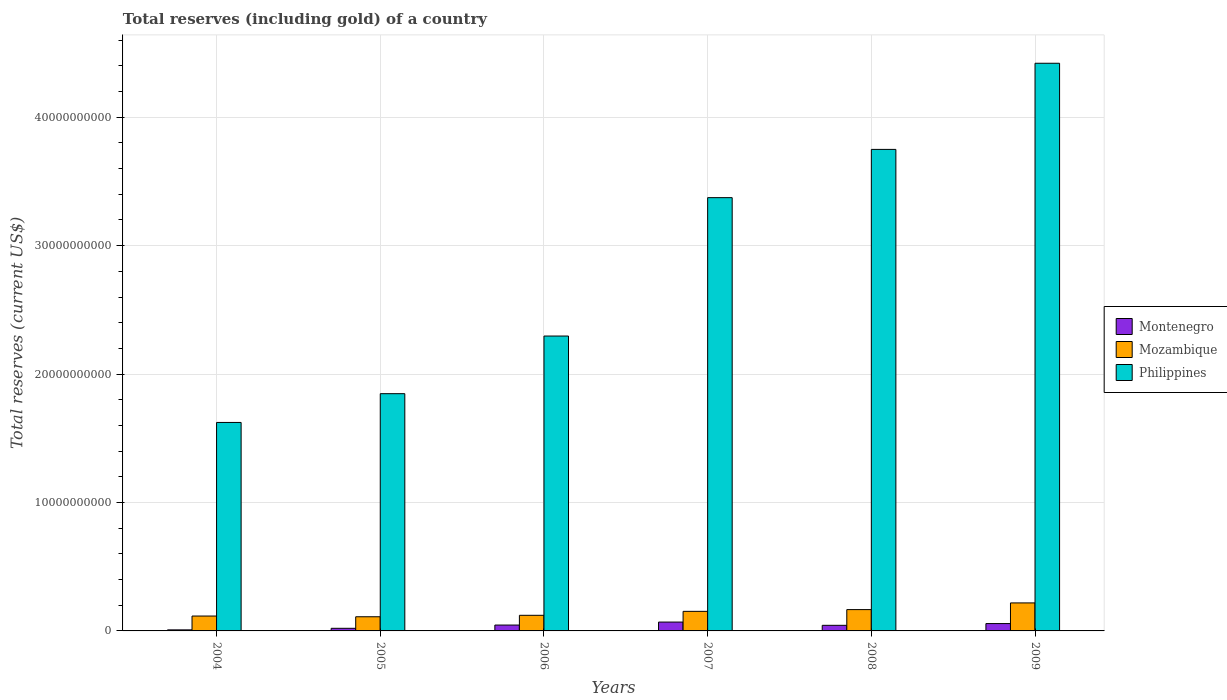Are the number of bars per tick equal to the number of legend labels?
Your answer should be very brief. Yes. How many bars are there on the 1st tick from the right?
Your answer should be compact. 3. What is the label of the 4th group of bars from the left?
Provide a succinct answer. 2007. What is the total reserves (including gold) in Mozambique in 2007?
Provide a short and direct response. 1.52e+09. Across all years, what is the maximum total reserves (including gold) in Montenegro?
Provide a short and direct response. 6.89e+08. Across all years, what is the minimum total reserves (including gold) in Montenegro?
Provide a short and direct response. 8.18e+07. In which year was the total reserves (including gold) in Mozambique minimum?
Make the answer very short. 2005. What is the total total reserves (including gold) in Mozambique in the graph?
Give a very brief answer. 8.84e+09. What is the difference between the total reserves (including gold) in Philippines in 2004 and that in 2009?
Offer a very short reply. -2.80e+1. What is the difference between the total reserves (including gold) in Philippines in 2006 and the total reserves (including gold) in Montenegro in 2004?
Provide a succinct answer. 2.29e+1. What is the average total reserves (including gold) in Mozambique per year?
Make the answer very short. 1.47e+09. In the year 2007, what is the difference between the total reserves (including gold) in Montenegro and total reserves (including gold) in Philippines?
Your answer should be compact. -3.31e+1. What is the ratio of the total reserves (including gold) in Philippines in 2006 to that in 2007?
Give a very brief answer. 0.68. Is the total reserves (including gold) in Montenegro in 2007 less than that in 2008?
Provide a short and direct response. No. What is the difference between the highest and the second highest total reserves (including gold) in Mozambique?
Ensure brevity in your answer.  5.21e+08. What is the difference between the highest and the lowest total reserves (including gold) in Mozambique?
Keep it short and to the point. 1.08e+09. Is the sum of the total reserves (including gold) in Philippines in 2005 and 2007 greater than the maximum total reserves (including gold) in Mozambique across all years?
Offer a very short reply. Yes. What does the 2nd bar from the left in 2004 represents?
Offer a very short reply. Mozambique. What does the 2nd bar from the right in 2004 represents?
Your answer should be compact. Mozambique. Are all the bars in the graph horizontal?
Keep it short and to the point. No. How many legend labels are there?
Your answer should be compact. 3. How are the legend labels stacked?
Your response must be concise. Vertical. What is the title of the graph?
Ensure brevity in your answer.  Total reserves (including gold) of a country. What is the label or title of the Y-axis?
Provide a short and direct response. Total reserves (current US$). What is the Total reserves (current US$) of Montenegro in 2004?
Offer a very short reply. 8.18e+07. What is the Total reserves (current US$) in Mozambique in 2004?
Your answer should be compact. 1.16e+09. What is the Total reserves (current US$) of Philippines in 2004?
Offer a very short reply. 1.62e+1. What is the Total reserves (current US$) of Montenegro in 2005?
Offer a very short reply. 2.04e+08. What is the Total reserves (current US$) of Mozambique in 2005?
Give a very brief answer. 1.10e+09. What is the Total reserves (current US$) of Philippines in 2005?
Provide a short and direct response. 1.85e+1. What is the Total reserves (current US$) of Montenegro in 2006?
Ensure brevity in your answer.  4.57e+08. What is the Total reserves (current US$) of Mozambique in 2006?
Your response must be concise. 1.22e+09. What is the Total reserves (current US$) of Philippines in 2006?
Provide a succinct answer. 2.30e+1. What is the Total reserves (current US$) in Montenegro in 2007?
Keep it short and to the point. 6.89e+08. What is the Total reserves (current US$) of Mozambique in 2007?
Ensure brevity in your answer.  1.52e+09. What is the Total reserves (current US$) of Philippines in 2007?
Offer a very short reply. 3.37e+1. What is the Total reserves (current US$) in Montenegro in 2008?
Offer a very short reply. 4.36e+08. What is the Total reserves (current US$) in Mozambique in 2008?
Give a very brief answer. 1.66e+09. What is the Total reserves (current US$) in Philippines in 2008?
Offer a very short reply. 3.75e+1. What is the Total reserves (current US$) in Montenegro in 2009?
Make the answer very short. 5.73e+08. What is the Total reserves (current US$) of Mozambique in 2009?
Your answer should be compact. 2.18e+09. What is the Total reserves (current US$) of Philippines in 2009?
Your response must be concise. 4.42e+1. Across all years, what is the maximum Total reserves (current US$) of Montenegro?
Offer a very short reply. 6.89e+08. Across all years, what is the maximum Total reserves (current US$) of Mozambique?
Ensure brevity in your answer.  2.18e+09. Across all years, what is the maximum Total reserves (current US$) in Philippines?
Ensure brevity in your answer.  4.42e+1. Across all years, what is the minimum Total reserves (current US$) in Montenegro?
Your response must be concise. 8.18e+07. Across all years, what is the minimum Total reserves (current US$) of Mozambique?
Provide a short and direct response. 1.10e+09. Across all years, what is the minimum Total reserves (current US$) of Philippines?
Offer a very short reply. 1.62e+1. What is the total Total reserves (current US$) in Montenegro in the graph?
Provide a short and direct response. 2.44e+09. What is the total Total reserves (current US$) of Mozambique in the graph?
Give a very brief answer. 8.84e+09. What is the total Total reserves (current US$) of Philippines in the graph?
Provide a short and direct response. 1.73e+11. What is the difference between the Total reserves (current US$) in Montenegro in 2004 and that in 2005?
Your response must be concise. -1.22e+08. What is the difference between the Total reserves (current US$) in Mozambique in 2004 and that in 2005?
Offer a very short reply. 5.66e+07. What is the difference between the Total reserves (current US$) of Philippines in 2004 and that in 2005?
Offer a terse response. -2.24e+09. What is the difference between the Total reserves (current US$) of Montenegro in 2004 and that in 2006?
Provide a succinct answer. -3.75e+08. What is the difference between the Total reserves (current US$) in Mozambique in 2004 and that in 2006?
Give a very brief answer. -5.69e+07. What is the difference between the Total reserves (current US$) in Philippines in 2004 and that in 2006?
Keep it short and to the point. -6.73e+09. What is the difference between the Total reserves (current US$) in Montenegro in 2004 and that in 2007?
Offer a very short reply. -6.07e+08. What is the difference between the Total reserves (current US$) in Mozambique in 2004 and that in 2007?
Provide a succinct answer. -3.65e+08. What is the difference between the Total reserves (current US$) of Philippines in 2004 and that in 2007?
Your response must be concise. -1.75e+1. What is the difference between the Total reserves (current US$) in Montenegro in 2004 and that in 2008?
Provide a short and direct response. -3.54e+08. What is the difference between the Total reserves (current US$) in Mozambique in 2004 and that in 2008?
Offer a terse response. -5.01e+08. What is the difference between the Total reserves (current US$) in Philippines in 2004 and that in 2008?
Your answer should be very brief. -2.13e+1. What is the difference between the Total reserves (current US$) in Montenegro in 2004 and that in 2009?
Ensure brevity in your answer.  -4.91e+08. What is the difference between the Total reserves (current US$) of Mozambique in 2004 and that in 2009?
Offer a terse response. -1.02e+09. What is the difference between the Total reserves (current US$) in Philippines in 2004 and that in 2009?
Offer a terse response. -2.80e+1. What is the difference between the Total reserves (current US$) of Montenegro in 2005 and that in 2006?
Offer a terse response. -2.53e+08. What is the difference between the Total reserves (current US$) of Mozambique in 2005 and that in 2006?
Provide a succinct answer. -1.14e+08. What is the difference between the Total reserves (current US$) of Philippines in 2005 and that in 2006?
Give a very brief answer. -4.49e+09. What is the difference between the Total reserves (current US$) of Montenegro in 2005 and that in 2007?
Provide a short and direct response. -4.85e+08. What is the difference between the Total reserves (current US$) of Mozambique in 2005 and that in 2007?
Your answer should be compact. -4.21e+08. What is the difference between the Total reserves (current US$) of Philippines in 2005 and that in 2007?
Keep it short and to the point. -1.53e+1. What is the difference between the Total reserves (current US$) of Montenegro in 2005 and that in 2008?
Your answer should be very brief. -2.32e+08. What is the difference between the Total reserves (current US$) in Mozambique in 2005 and that in 2008?
Your answer should be very brief. -5.58e+08. What is the difference between the Total reserves (current US$) of Philippines in 2005 and that in 2008?
Provide a succinct answer. -1.90e+1. What is the difference between the Total reserves (current US$) in Montenegro in 2005 and that in 2009?
Provide a short and direct response. -3.69e+08. What is the difference between the Total reserves (current US$) of Mozambique in 2005 and that in 2009?
Ensure brevity in your answer.  -1.08e+09. What is the difference between the Total reserves (current US$) of Philippines in 2005 and that in 2009?
Give a very brief answer. -2.57e+1. What is the difference between the Total reserves (current US$) in Montenegro in 2006 and that in 2007?
Offer a terse response. -2.32e+08. What is the difference between the Total reserves (current US$) in Mozambique in 2006 and that in 2007?
Give a very brief answer. -3.08e+08. What is the difference between the Total reserves (current US$) of Philippines in 2006 and that in 2007?
Offer a terse response. -1.08e+1. What is the difference between the Total reserves (current US$) of Montenegro in 2006 and that in 2008?
Your answer should be very brief. 2.15e+07. What is the difference between the Total reserves (current US$) in Mozambique in 2006 and that in 2008?
Your answer should be compact. -4.44e+08. What is the difference between the Total reserves (current US$) of Philippines in 2006 and that in 2008?
Provide a short and direct response. -1.45e+1. What is the difference between the Total reserves (current US$) of Montenegro in 2006 and that in 2009?
Provide a succinct answer. -1.15e+08. What is the difference between the Total reserves (current US$) in Mozambique in 2006 and that in 2009?
Ensure brevity in your answer.  -9.65e+08. What is the difference between the Total reserves (current US$) of Philippines in 2006 and that in 2009?
Give a very brief answer. -2.12e+1. What is the difference between the Total reserves (current US$) of Montenegro in 2007 and that in 2008?
Your answer should be compact. 2.53e+08. What is the difference between the Total reserves (current US$) in Mozambique in 2007 and that in 2008?
Offer a terse response. -1.36e+08. What is the difference between the Total reserves (current US$) of Philippines in 2007 and that in 2008?
Ensure brevity in your answer.  -3.76e+09. What is the difference between the Total reserves (current US$) of Montenegro in 2007 and that in 2009?
Make the answer very short. 1.16e+08. What is the difference between the Total reserves (current US$) of Mozambique in 2007 and that in 2009?
Make the answer very short. -6.57e+08. What is the difference between the Total reserves (current US$) in Philippines in 2007 and that in 2009?
Your response must be concise. -1.05e+1. What is the difference between the Total reserves (current US$) of Montenegro in 2008 and that in 2009?
Your answer should be compact. -1.37e+08. What is the difference between the Total reserves (current US$) in Mozambique in 2008 and that in 2009?
Keep it short and to the point. -5.21e+08. What is the difference between the Total reserves (current US$) of Philippines in 2008 and that in 2009?
Your response must be concise. -6.71e+09. What is the difference between the Total reserves (current US$) of Montenegro in 2004 and the Total reserves (current US$) of Mozambique in 2005?
Provide a short and direct response. -1.02e+09. What is the difference between the Total reserves (current US$) of Montenegro in 2004 and the Total reserves (current US$) of Philippines in 2005?
Give a very brief answer. -1.84e+1. What is the difference between the Total reserves (current US$) of Mozambique in 2004 and the Total reserves (current US$) of Philippines in 2005?
Make the answer very short. -1.73e+1. What is the difference between the Total reserves (current US$) of Montenegro in 2004 and the Total reserves (current US$) of Mozambique in 2006?
Your response must be concise. -1.13e+09. What is the difference between the Total reserves (current US$) in Montenegro in 2004 and the Total reserves (current US$) in Philippines in 2006?
Provide a short and direct response. -2.29e+1. What is the difference between the Total reserves (current US$) of Mozambique in 2004 and the Total reserves (current US$) of Philippines in 2006?
Offer a terse response. -2.18e+1. What is the difference between the Total reserves (current US$) in Montenegro in 2004 and the Total reserves (current US$) in Mozambique in 2007?
Your answer should be compact. -1.44e+09. What is the difference between the Total reserves (current US$) of Montenegro in 2004 and the Total reserves (current US$) of Philippines in 2007?
Give a very brief answer. -3.37e+1. What is the difference between the Total reserves (current US$) in Mozambique in 2004 and the Total reserves (current US$) in Philippines in 2007?
Give a very brief answer. -3.26e+1. What is the difference between the Total reserves (current US$) of Montenegro in 2004 and the Total reserves (current US$) of Mozambique in 2008?
Offer a terse response. -1.58e+09. What is the difference between the Total reserves (current US$) of Montenegro in 2004 and the Total reserves (current US$) of Philippines in 2008?
Your response must be concise. -3.74e+1. What is the difference between the Total reserves (current US$) in Mozambique in 2004 and the Total reserves (current US$) in Philippines in 2008?
Ensure brevity in your answer.  -3.63e+1. What is the difference between the Total reserves (current US$) of Montenegro in 2004 and the Total reserves (current US$) of Mozambique in 2009?
Provide a succinct answer. -2.10e+09. What is the difference between the Total reserves (current US$) in Montenegro in 2004 and the Total reserves (current US$) in Philippines in 2009?
Ensure brevity in your answer.  -4.41e+1. What is the difference between the Total reserves (current US$) in Mozambique in 2004 and the Total reserves (current US$) in Philippines in 2009?
Give a very brief answer. -4.30e+1. What is the difference between the Total reserves (current US$) of Montenegro in 2005 and the Total reserves (current US$) of Mozambique in 2006?
Your response must be concise. -1.01e+09. What is the difference between the Total reserves (current US$) of Montenegro in 2005 and the Total reserves (current US$) of Philippines in 2006?
Offer a terse response. -2.28e+1. What is the difference between the Total reserves (current US$) in Mozambique in 2005 and the Total reserves (current US$) in Philippines in 2006?
Make the answer very short. -2.19e+1. What is the difference between the Total reserves (current US$) of Montenegro in 2005 and the Total reserves (current US$) of Mozambique in 2007?
Ensure brevity in your answer.  -1.32e+09. What is the difference between the Total reserves (current US$) of Montenegro in 2005 and the Total reserves (current US$) of Philippines in 2007?
Your answer should be very brief. -3.35e+1. What is the difference between the Total reserves (current US$) in Mozambique in 2005 and the Total reserves (current US$) in Philippines in 2007?
Offer a very short reply. -3.26e+1. What is the difference between the Total reserves (current US$) in Montenegro in 2005 and the Total reserves (current US$) in Mozambique in 2008?
Your response must be concise. -1.46e+09. What is the difference between the Total reserves (current US$) in Montenegro in 2005 and the Total reserves (current US$) in Philippines in 2008?
Offer a terse response. -3.73e+1. What is the difference between the Total reserves (current US$) of Mozambique in 2005 and the Total reserves (current US$) of Philippines in 2008?
Offer a terse response. -3.64e+1. What is the difference between the Total reserves (current US$) in Montenegro in 2005 and the Total reserves (current US$) in Mozambique in 2009?
Your answer should be compact. -1.98e+09. What is the difference between the Total reserves (current US$) of Montenegro in 2005 and the Total reserves (current US$) of Philippines in 2009?
Make the answer very short. -4.40e+1. What is the difference between the Total reserves (current US$) of Mozambique in 2005 and the Total reserves (current US$) of Philippines in 2009?
Offer a terse response. -4.31e+1. What is the difference between the Total reserves (current US$) in Montenegro in 2006 and the Total reserves (current US$) in Mozambique in 2007?
Keep it short and to the point. -1.07e+09. What is the difference between the Total reserves (current US$) in Montenegro in 2006 and the Total reserves (current US$) in Philippines in 2007?
Make the answer very short. -3.33e+1. What is the difference between the Total reserves (current US$) in Mozambique in 2006 and the Total reserves (current US$) in Philippines in 2007?
Your answer should be very brief. -3.25e+1. What is the difference between the Total reserves (current US$) of Montenegro in 2006 and the Total reserves (current US$) of Mozambique in 2008?
Offer a terse response. -1.20e+09. What is the difference between the Total reserves (current US$) of Montenegro in 2006 and the Total reserves (current US$) of Philippines in 2008?
Give a very brief answer. -3.70e+1. What is the difference between the Total reserves (current US$) of Mozambique in 2006 and the Total reserves (current US$) of Philippines in 2008?
Provide a succinct answer. -3.63e+1. What is the difference between the Total reserves (current US$) of Montenegro in 2006 and the Total reserves (current US$) of Mozambique in 2009?
Offer a very short reply. -1.72e+09. What is the difference between the Total reserves (current US$) of Montenegro in 2006 and the Total reserves (current US$) of Philippines in 2009?
Provide a short and direct response. -4.37e+1. What is the difference between the Total reserves (current US$) in Mozambique in 2006 and the Total reserves (current US$) in Philippines in 2009?
Your answer should be compact. -4.30e+1. What is the difference between the Total reserves (current US$) in Montenegro in 2007 and the Total reserves (current US$) in Mozambique in 2008?
Your response must be concise. -9.72e+08. What is the difference between the Total reserves (current US$) of Montenegro in 2007 and the Total reserves (current US$) of Philippines in 2008?
Give a very brief answer. -3.68e+1. What is the difference between the Total reserves (current US$) of Mozambique in 2007 and the Total reserves (current US$) of Philippines in 2008?
Offer a very short reply. -3.60e+1. What is the difference between the Total reserves (current US$) of Montenegro in 2007 and the Total reserves (current US$) of Mozambique in 2009?
Provide a succinct answer. -1.49e+09. What is the difference between the Total reserves (current US$) of Montenegro in 2007 and the Total reserves (current US$) of Philippines in 2009?
Keep it short and to the point. -4.35e+1. What is the difference between the Total reserves (current US$) in Mozambique in 2007 and the Total reserves (current US$) in Philippines in 2009?
Provide a succinct answer. -4.27e+1. What is the difference between the Total reserves (current US$) in Montenegro in 2008 and the Total reserves (current US$) in Mozambique in 2009?
Offer a terse response. -1.75e+09. What is the difference between the Total reserves (current US$) in Montenegro in 2008 and the Total reserves (current US$) in Philippines in 2009?
Provide a short and direct response. -4.38e+1. What is the difference between the Total reserves (current US$) of Mozambique in 2008 and the Total reserves (current US$) of Philippines in 2009?
Provide a short and direct response. -4.25e+1. What is the average Total reserves (current US$) in Montenegro per year?
Your answer should be very brief. 4.07e+08. What is the average Total reserves (current US$) of Mozambique per year?
Keep it short and to the point. 1.47e+09. What is the average Total reserves (current US$) of Philippines per year?
Ensure brevity in your answer.  2.89e+1. In the year 2004, what is the difference between the Total reserves (current US$) in Montenegro and Total reserves (current US$) in Mozambique?
Keep it short and to the point. -1.08e+09. In the year 2004, what is the difference between the Total reserves (current US$) of Montenegro and Total reserves (current US$) of Philippines?
Your response must be concise. -1.62e+1. In the year 2004, what is the difference between the Total reserves (current US$) in Mozambique and Total reserves (current US$) in Philippines?
Provide a short and direct response. -1.51e+1. In the year 2005, what is the difference between the Total reserves (current US$) of Montenegro and Total reserves (current US$) of Mozambique?
Your answer should be compact. -8.99e+08. In the year 2005, what is the difference between the Total reserves (current US$) in Montenegro and Total reserves (current US$) in Philippines?
Your response must be concise. -1.83e+1. In the year 2005, what is the difference between the Total reserves (current US$) of Mozambique and Total reserves (current US$) of Philippines?
Provide a short and direct response. -1.74e+1. In the year 2006, what is the difference between the Total reserves (current US$) in Montenegro and Total reserves (current US$) in Mozambique?
Your response must be concise. -7.59e+08. In the year 2006, what is the difference between the Total reserves (current US$) of Montenegro and Total reserves (current US$) of Philippines?
Offer a terse response. -2.25e+1. In the year 2006, what is the difference between the Total reserves (current US$) of Mozambique and Total reserves (current US$) of Philippines?
Your answer should be compact. -2.17e+1. In the year 2007, what is the difference between the Total reserves (current US$) in Montenegro and Total reserves (current US$) in Mozambique?
Your answer should be very brief. -8.35e+08. In the year 2007, what is the difference between the Total reserves (current US$) of Montenegro and Total reserves (current US$) of Philippines?
Provide a succinct answer. -3.31e+1. In the year 2007, what is the difference between the Total reserves (current US$) of Mozambique and Total reserves (current US$) of Philippines?
Make the answer very short. -3.22e+1. In the year 2008, what is the difference between the Total reserves (current US$) of Montenegro and Total reserves (current US$) of Mozambique?
Give a very brief answer. -1.22e+09. In the year 2008, what is the difference between the Total reserves (current US$) in Montenegro and Total reserves (current US$) in Philippines?
Offer a very short reply. -3.71e+1. In the year 2008, what is the difference between the Total reserves (current US$) in Mozambique and Total reserves (current US$) in Philippines?
Your answer should be very brief. -3.58e+1. In the year 2009, what is the difference between the Total reserves (current US$) in Montenegro and Total reserves (current US$) in Mozambique?
Your answer should be compact. -1.61e+09. In the year 2009, what is the difference between the Total reserves (current US$) of Montenegro and Total reserves (current US$) of Philippines?
Give a very brief answer. -4.36e+1. In the year 2009, what is the difference between the Total reserves (current US$) of Mozambique and Total reserves (current US$) of Philippines?
Offer a very short reply. -4.20e+1. What is the ratio of the Total reserves (current US$) of Montenegro in 2004 to that in 2005?
Keep it short and to the point. 0.4. What is the ratio of the Total reserves (current US$) of Mozambique in 2004 to that in 2005?
Offer a terse response. 1.05. What is the ratio of the Total reserves (current US$) of Philippines in 2004 to that in 2005?
Make the answer very short. 0.88. What is the ratio of the Total reserves (current US$) in Montenegro in 2004 to that in 2006?
Provide a short and direct response. 0.18. What is the ratio of the Total reserves (current US$) in Mozambique in 2004 to that in 2006?
Provide a succinct answer. 0.95. What is the ratio of the Total reserves (current US$) in Philippines in 2004 to that in 2006?
Ensure brevity in your answer.  0.71. What is the ratio of the Total reserves (current US$) in Montenegro in 2004 to that in 2007?
Provide a short and direct response. 0.12. What is the ratio of the Total reserves (current US$) of Mozambique in 2004 to that in 2007?
Your answer should be compact. 0.76. What is the ratio of the Total reserves (current US$) in Philippines in 2004 to that in 2007?
Your answer should be compact. 0.48. What is the ratio of the Total reserves (current US$) in Montenegro in 2004 to that in 2008?
Your answer should be very brief. 0.19. What is the ratio of the Total reserves (current US$) in Mozambique in 2004 to that in 2008?
Provide a succinct answer. 0.7. What is the ratio of the Total reserves (current US$) in Philippines in 2004 to that in 2008?
Offer a very short reply. 0.43. What is the ratio of the Total reserves (current US$) of Montenegro in 2004 to that in 2009?
Keep it short and to the point. 0.14. What is the ratio of the Total reserves (current US$) in Mozambique in 2004 to that in 2009?
Provide a short and direct response. 0.53. What is the ratio of the Total reserves (current US$) of Philippines in 2004 to that in 2009?
Ensure brevity in your answer.  0.37. What is the ratio of the Total reserves (current US$) in Montenegro in 2005 to that in 2006?
Your response must be concise. 0.45. What is the ratio of the Total reserves (current US$) in Mozambique in 2005 to that in 2006?
Your answer should be compact. 0.91. What is the ratio of the Total reserves (current US$) in Philippines in 2005 to that in 2006?
Ensure brevity in your answer.  0.8. What is the ratio of the Total reserves (current US$) in Montenegro in 2005 to that in 2007?
Your answer should be very brief. 0.3. What is the ratio of the Total reserves (current US$) of Mozambique in 2005 to that in 2007?
Your answer should be compact. 0.72. What is the ratio of the Total reserves (current US$) in Philippines in 2005 to that in 2007?
Offer a very short reply. 0.55. What is the ratio of the Total reserves (current US$) in Montenegro in 2005 to that in 2008?
Offer a very short reply. 0.47. What is the ratio of the Total reserves (current US$) in Mozambique in 2005 to that in 2008?
Your response must be concise. 0.66. What is the ratio of the Total reserves (current US$) in Philippines in 2005 to that in 2008?
Provide a succinct answer. 0.49. What is the ratio of the Total reserves (current US$) of Montenegro in 2005 to that in 2009?
Your answer should be compact. 0.36. What is the ratio of the Total reserves (current US$) of Mozambique in 2005 to that in 2009?
Offer a very short reply. 0.51. What is the ratio of the Total reserves (current US$) of Philippines in 2005 to that in 2009?
Ensure brevity in your answer.  0.42. What is the ratio of the Total reserves (current US$) of Montenegro in 2006 to that in 2007?
Provide a succinct answer. 0.66. What is the ratio of the Total reserves (current US$) of Mozambique in 2006 to that in 2007?
Your answer should be very brief. 0.8. What is the ratio of the Total reserves (current US$) of Philippines in 2006 to that in 2007?
Your answer should be compact. 0.68. What is the ratio of the Total reserves (current US$) of Montenegro in 2006 to that in 2008?
Provide a short and direct response. 1.05. What is the ratio of the Total reserves (current US$) in Mozambique in 2006 to that in 2008?
Your response must be concise. 0.73. What is the ratio of the Total reserves (current US$) of Philippines in 2006 to that in 2008?
Your response must be concise. 0.61. What is the ratio of the Total reserves (current US$) in Montenegro in 2006 to that in 2009?
Provide a succinct answer. 0.8. What is the ratio of the Total reserves (current US$) in Mozambique in 2006 to that in 2009?
Provide a short and direct response. 0.56. What is the ratio of the Total reserves (current US$) in Philippines in 2006 to that in 2009?
Give a very brief answer. 0.52. What is the ratio of the Total reserves (current US$) in Montenegro in 2007 to that in 2008?
Your response must be concise. 1.58. What is the ratio of the Total reserves (current US$) of Mozambique in 2007 to that in 2008?
Your response must be concise. 0.92. What is the ratio of the Total reserves (current US$) in Philippines in 2007 to that in 2008?
Provide a short and direct response. 0.9. What is the ratio of the Total reserves (current US$) of Montenegro in 2007 to that in 2009?
Provide a succinct answer. 1.2. What is the ratio of the Total reserves (current US$) in Mozambique in 2007 to that in 2009?
Offer a terse response. 0.7. What is the ratio of the Total reserves (current US$) in Philippines in 2007 to that in 2009?
Ensure brevity in your answer.  0.76. What is the ratio of the Total reserves (current US$) in Montenegro in 2008 to that in 2009?
Offer a very short reply. 0.76. What is the ratio of the Total reserves (current US$) in Mozambique in 2008 to that in 2009?
Keep it short and to the point. 0.76. What is the ratio of the Total reserves (current US$) of Philippines in 2008 to that in 2009?
Give a very brief answer. 0.85. What is the difference between the highest and the second highest Total reserves (current US$) of Montenegro?
Provide a succinct answer. 1.16e+08. What is the difference between the highest and the second highest Total reserves (current US$) of Mozambique?
Your answer should be very brief. 5.21e+08. What is the difference between the highest and the second highest Total reserves (current US$) of Philippines?
Make the answer very short. 6.71e+09. What is the difference between the highest and the lowest Total reserves (current US$) in Montenegro?
Your answer should be compact. 6.07e+08. What is the difference between the highest and the lowest Total reserves (current US$) in Mozambique?
Give a very brief answer. 1.08e+09. What is the difference between the highest and the lowest Total reserves (current US$) in Philippines?
Your answer should be very brief. 2.80e+1. 